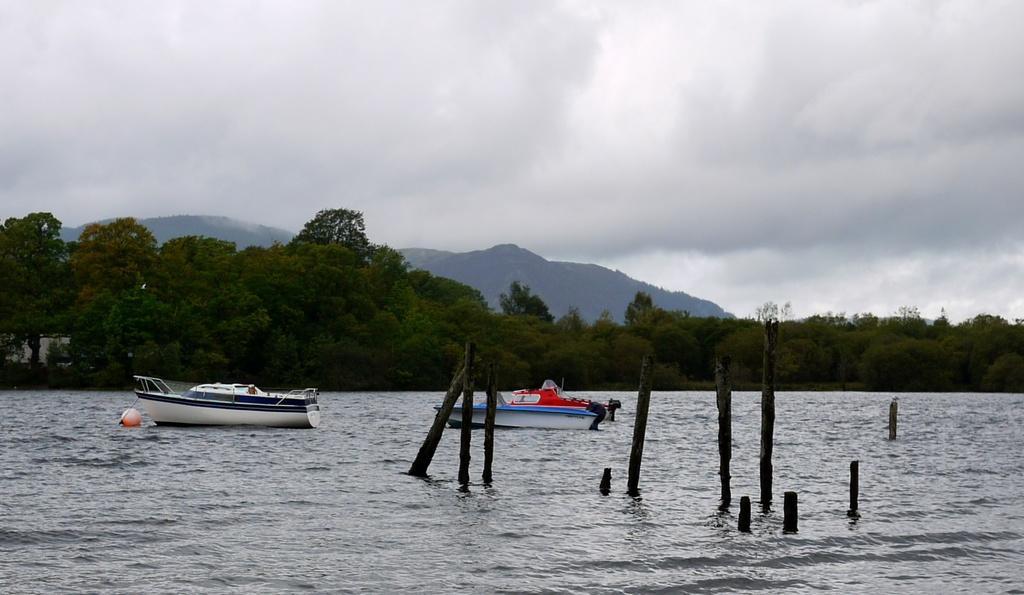In one or two sentences, can you explain what this image depicts? In this image we can see water. There are boats on the water. Also there are wooden poles in the water. In the background there are trees, hills and sky in the background. 